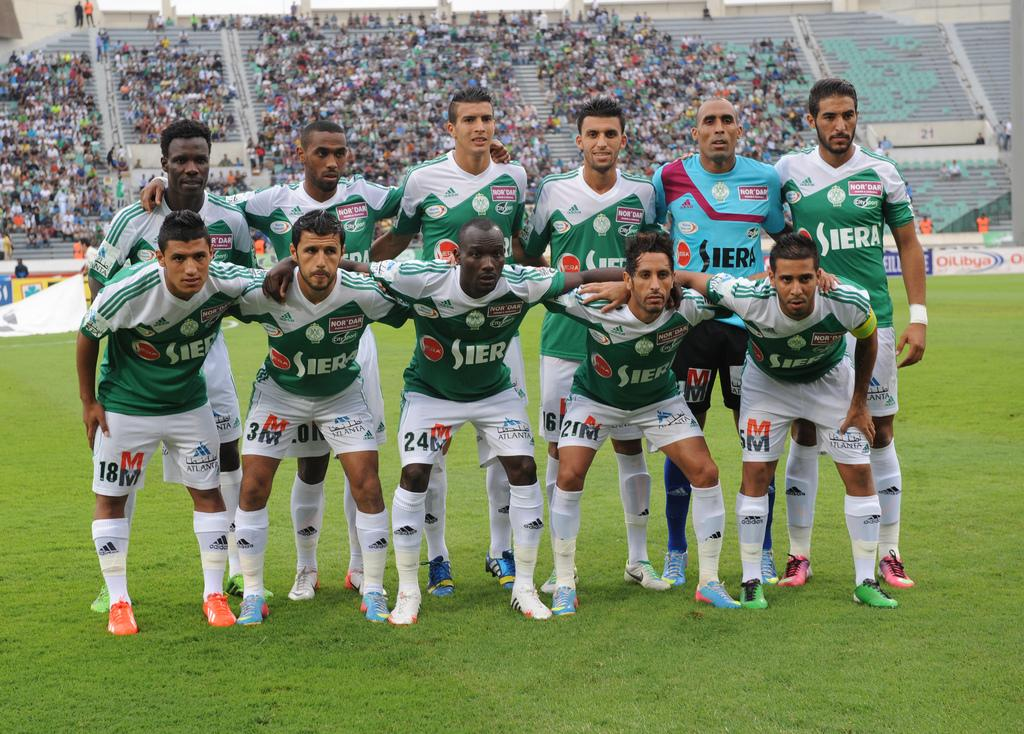<image>
Offer a succinct explanation of the picture presented. The soccer team is sponsored by a company called Siera. 